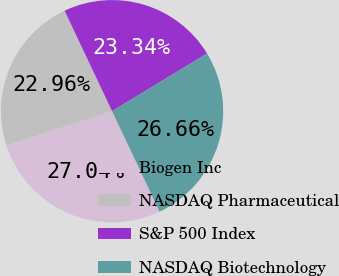Convert chart. <chart><loc_0><loc_0><loc_500><loc_500><pie_chart><fcel>Biogen Inc<fcel>NASDAQ Pharmaceutical<fcel>S&P 500 Index<fcel>NASDAQ Biotechnology<nl><fcel>27.04%<fcel>22.96%<fcel>23.34%<fcel>26.66%<nl></chart> 